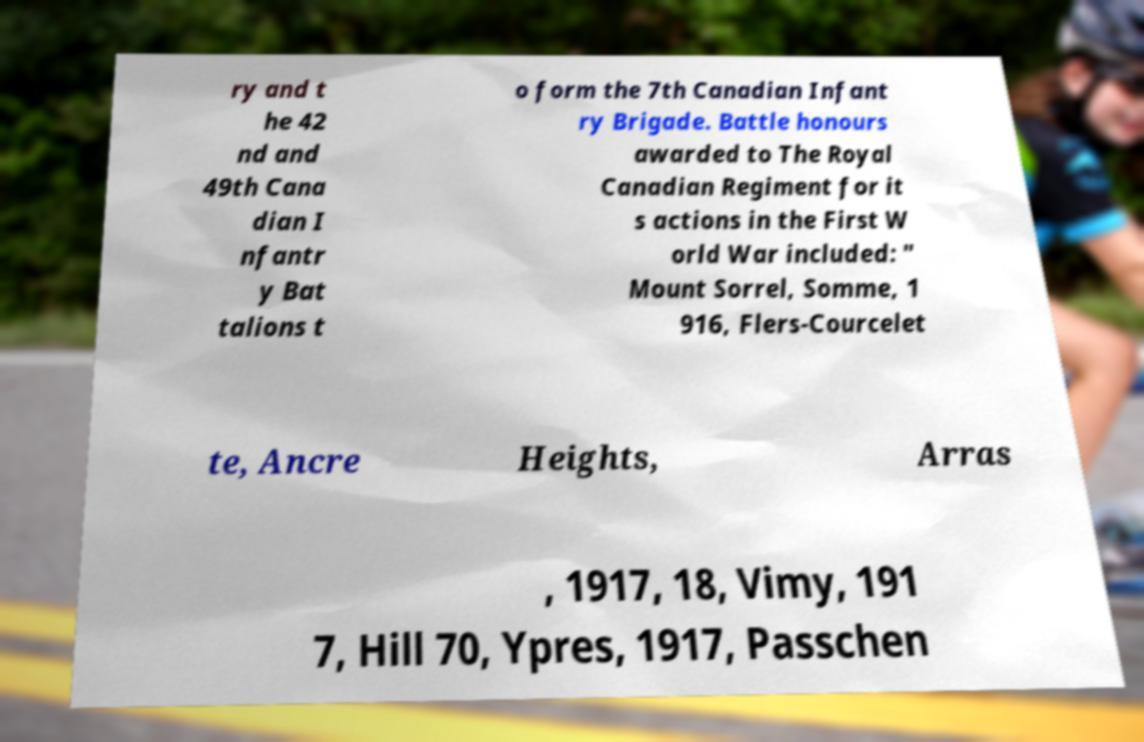Please read and relay the text visible in this image. What does it say? ry and t he 42 nd and 49th Cana dian I nfantr y Bat talions t o form the 7th Canadian Infant ry Brigade. Battle honours awarded to The Royal Canadian Regiment for it s actions in the First W orld War included: " Mount Sorrel, Somme, 1 916, Flers-Courcelet te, Ancre Heights, Arras , 1917, 18, Vimy, 191 7, Hill 70, Ypres, 1917, Passchen 